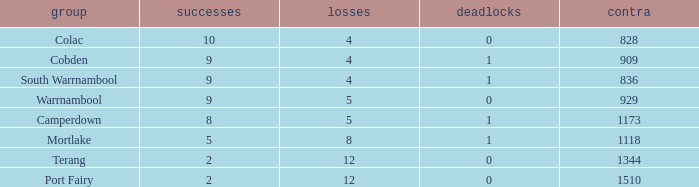What is the total number of Against values for clubs with more than 2 wins, 5 losses, and 0 draws? 0.0. 